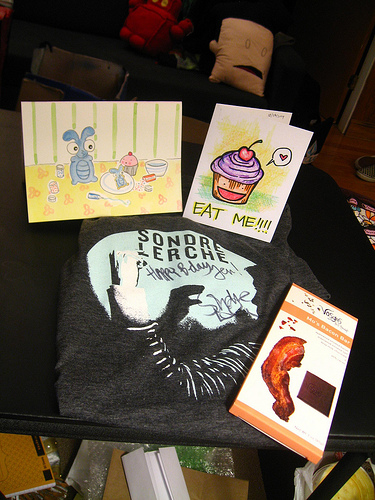<image>
Is there a one behind the two? No. The one is not behind the two. From this viewpoint, the one appears to be positioned elsewhere in the scene. 